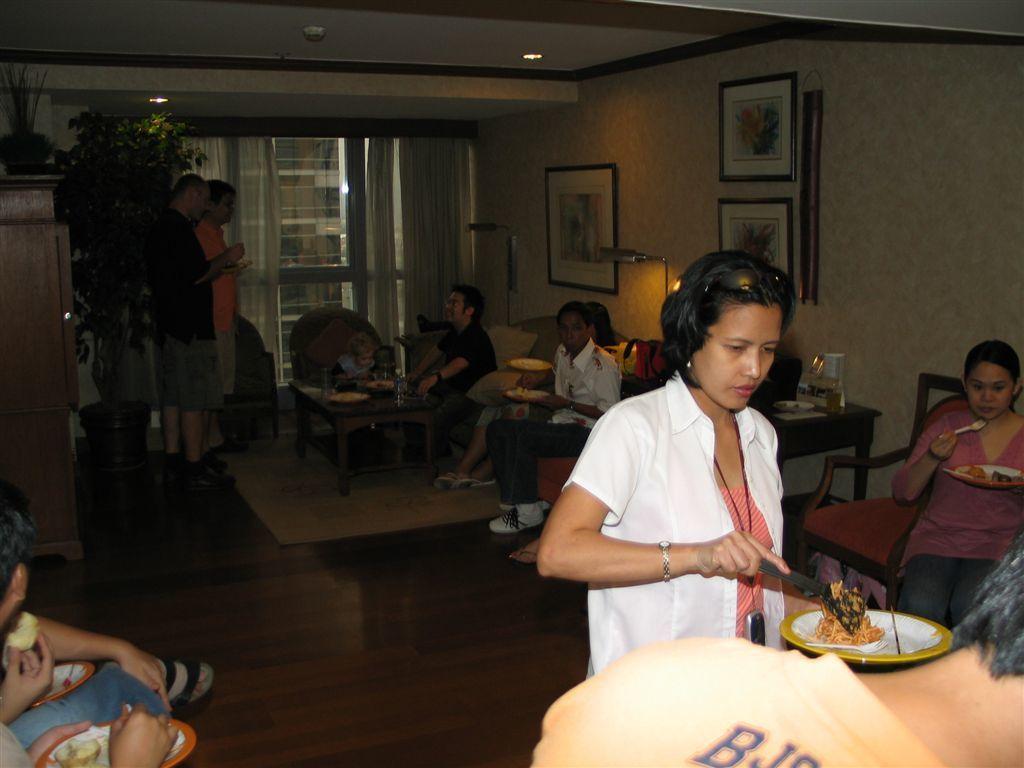In one or two sentences, can you explain what this image depicts? In this picture are there is a woman serving food and half in half plate and in the background as some people sitting and standing. 